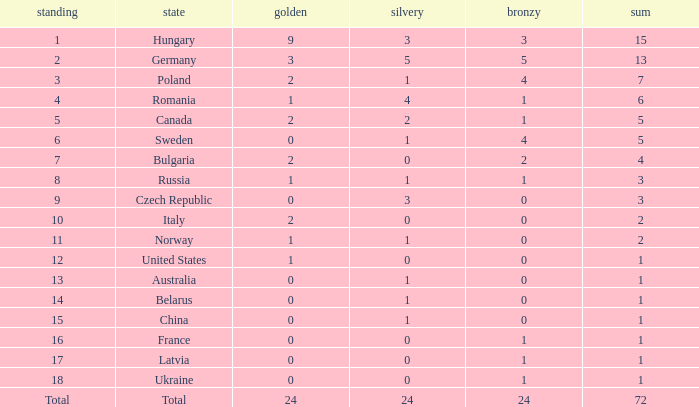What average total has 0 as the gold, with 6 as the rank? 5.0. 